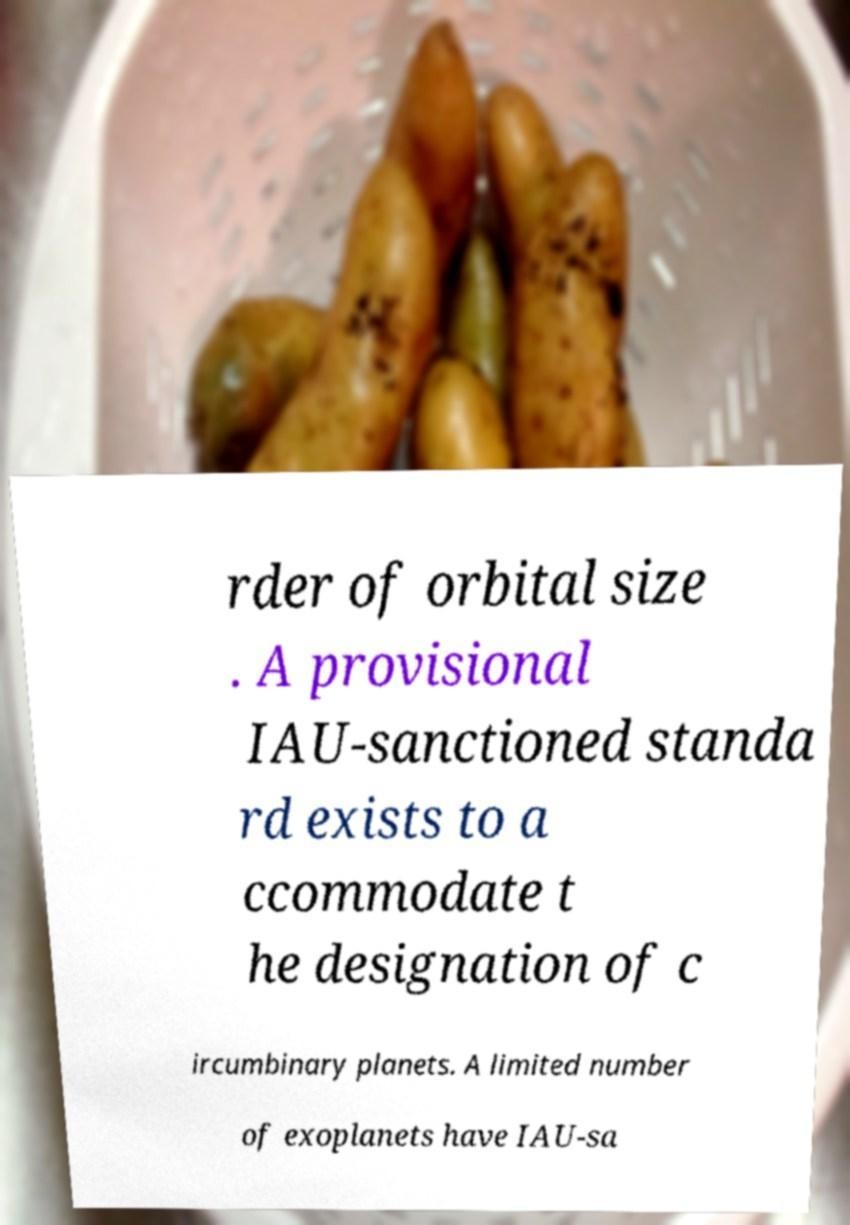I need the written content from this picture converted into text. Can you do that? rder of orbital size . A provisional IAU-sanctioned standa rd exists to a ccommodate t he designation of c ircumbinary planets. A limited number of exoplanets have IAU-sa 